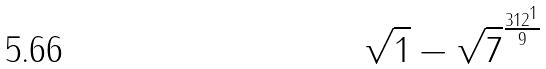<formula> <loc_0><loc_0><loc_500><loc_500>\sqrt { 1 } - \sqrt { 7 } ^ { \frac { 3 1 2 ^ { 1 } } { 9 } }</formula> 